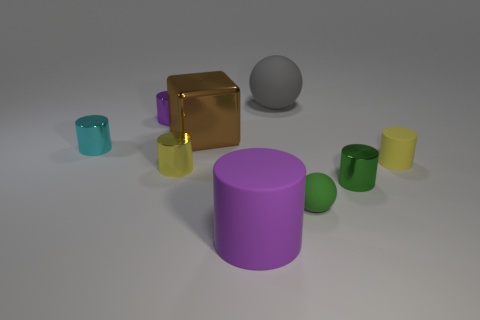Subtract all yellow cylinders. How many cylinders are left? 4 Add 1 green cylinders. How many objects exist? 10 Subtract all yellow cylinders. How many gray blocks are left? 0 Subtract all gray spheres. How many spheres are left? 1 Subtract 1 balls. How many balls are left? 1 Subtract all green cylinders. Subtract all red balls. How many cylinders are left? 5 Add 5 small purple balls. How many small purple balls exist? 5 Subtract 0 cyan spheres. How many objects are left? 9 Subtract all cylinders. How many objects are left? 3 Subtract all large gray spheres. Subtract all cyan objects. How many objects are left? 7 